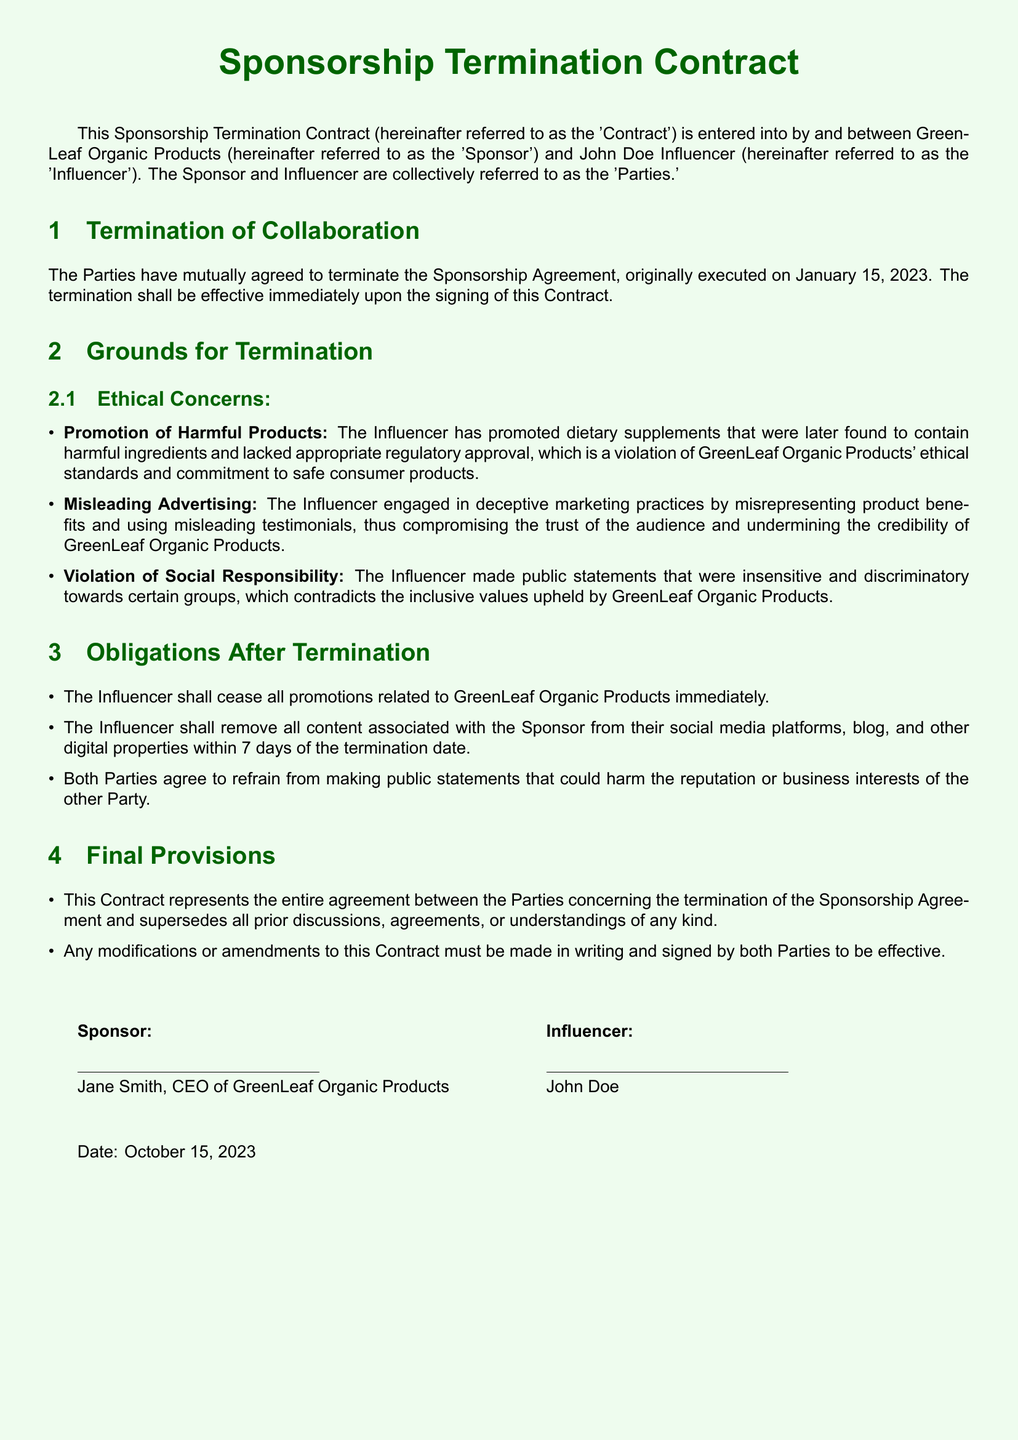What is the date of the termination contract? The date of the termination contract is provided in the final section, which indicates when the agreement was signed.
Answer: October 15, 2023 Who is the CEO of GreenLeaf Organic Products? The document lists the CEO of GreenLeaf Organic Products in the final authorization section.
Answer: Jane Smith What are the ethical concerns listed for termination? The document outlines specific ethical concerns under the "Grounds for Termination" section, listing multiple issues.
Answer: Promotion of Harmful Products, Misleading Advertising, Violation of Social Responsibility How many days does the influencer have to remove the content after termination? The obligations post-termination specify a timeframe for content removal.
Answer: 7 days What type of marketing practices did the influencer engage in? The document refers to specific actions taken by the influencer under the ethical concerns section.
Answer: Deceptive marketing practices What is the contract meant to terminate? The contract explicitly states its purpose in the introductory section.
Answer: The Sponsorship Agreement What must be done for any modifications to this contract? The document details the necessary conditions for changes to the contract in the "Final Provisions" section.
Answer: Made in writing and signed by both Parties What phrase describes the overall agreement between the Parties? The conclusion of the contract summarizes the nature of the agreement between the Parties.
Answer: Entire agreement 